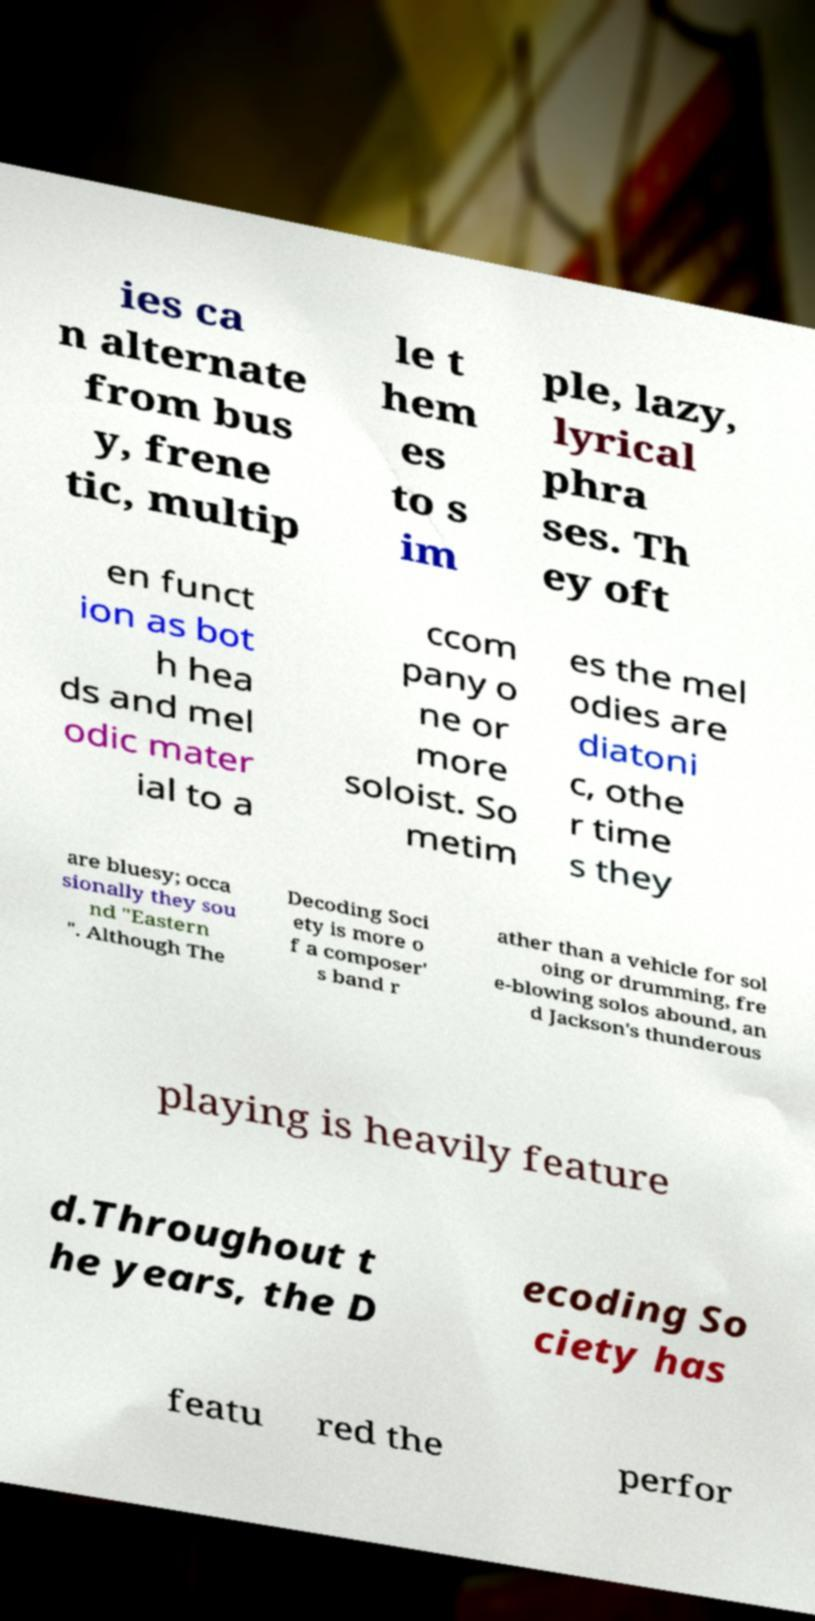For documentation purposes, I need the text within this image transcribed. Could you provide that? ies ca n alternate from bus y, frene tic, multip le t hem es to s im ple, lazy, lyrical phra ses. Th ey oft en funct ion as bot h hea ds and mel odic mater ial to a ccom pany o ne or more soloist. So metim es the mel odies are diatoni c, othe r time s they are bluesy; occa sionally they sou nd "Eastern ". Although The Decoding Soci ety is more o f a composer' s band r ather than a vehicle for sol oing or drumming, fre e-blowing solos abound, an d Jackson's thunderous playing is heavily feature d.Throughout t he years, the D ecoding So ciety has featu red the perfor 